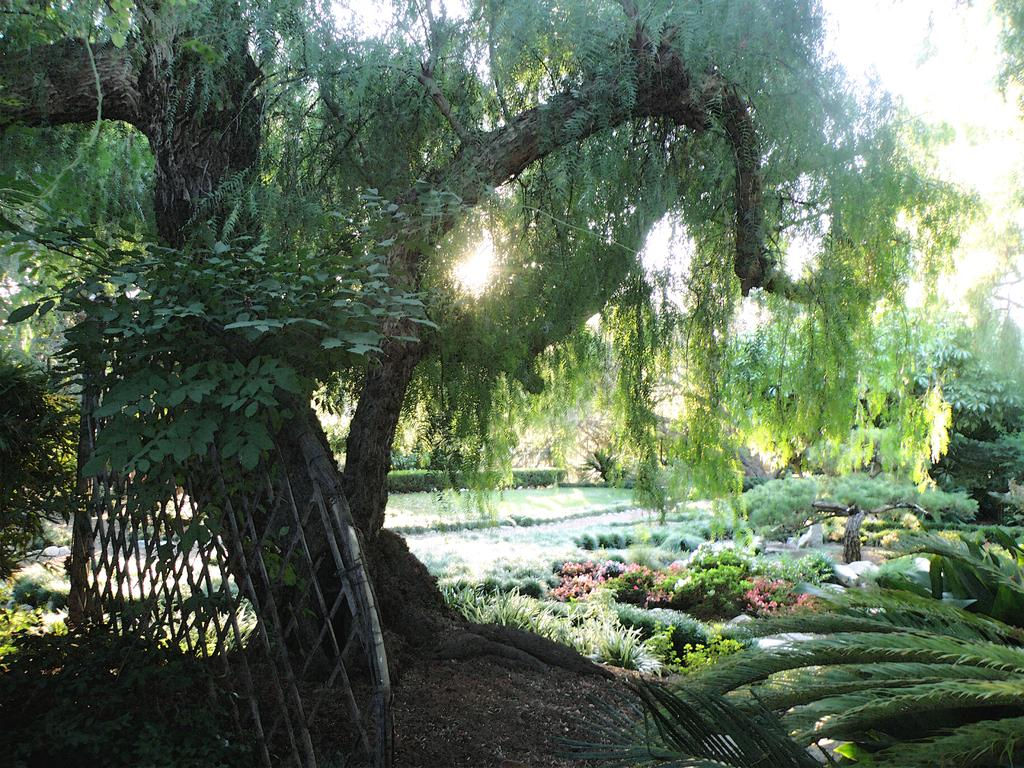What type of plant can be seen in the image? There is a tree in the image. What is in front of the tree? There is a wooden fence in front of the tree. What can be seen in the background of the image? In the background of the image, there are flowers, plants, leaves, and bushes. What type of cushion is on the tree in the image? There is no cushion on the tree in the image. 